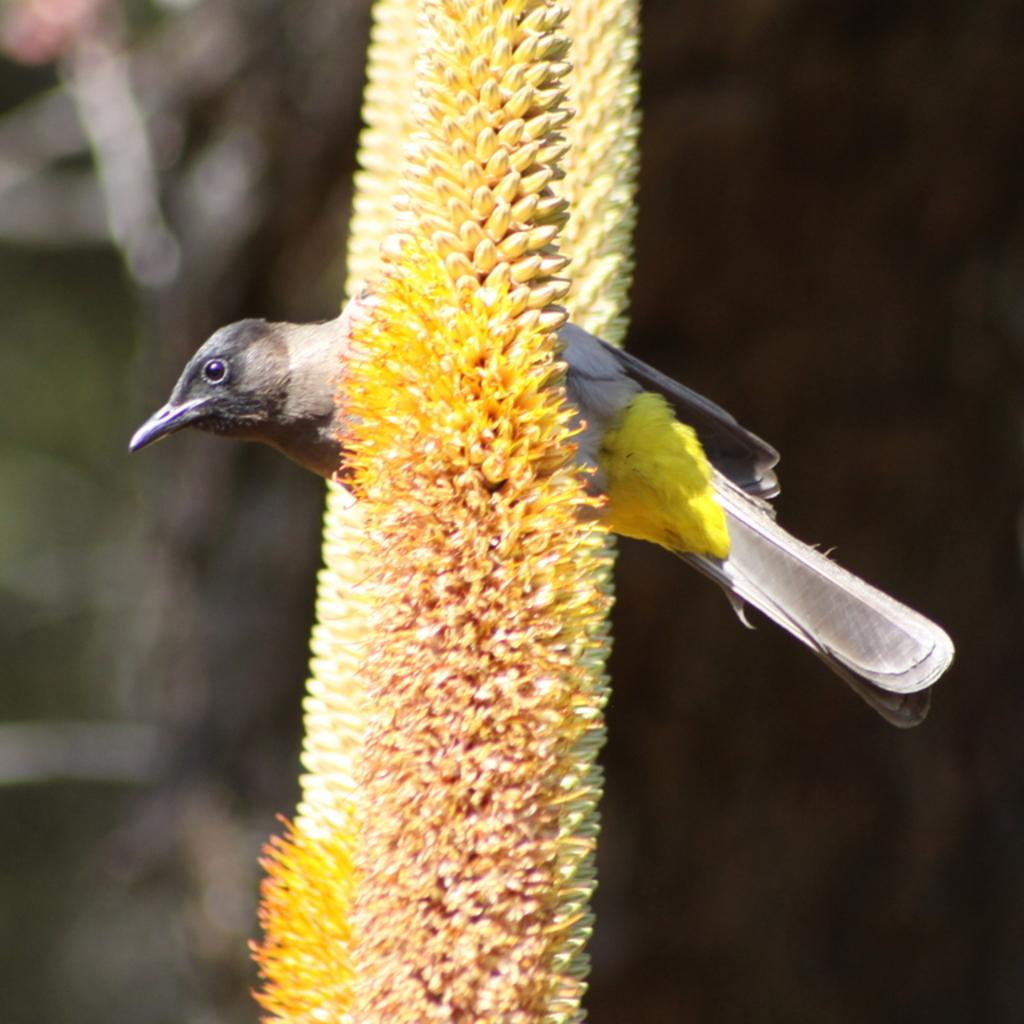What type of animal is in the image? There is a bird in the image. What is the bird perched on? The bird is on a yellow and cream color plant. What colors can be seen on the bird? The bird has black and yellow coloring. How would you describe the background of the image? The background of the image is blurred. What type of mark can be seen on the bird's wing in the image? There is no mark visible on the bird's wing in the image. What drink is the bird holding in its beak in the image? The bird is not holding any drink in its beak in the image. 